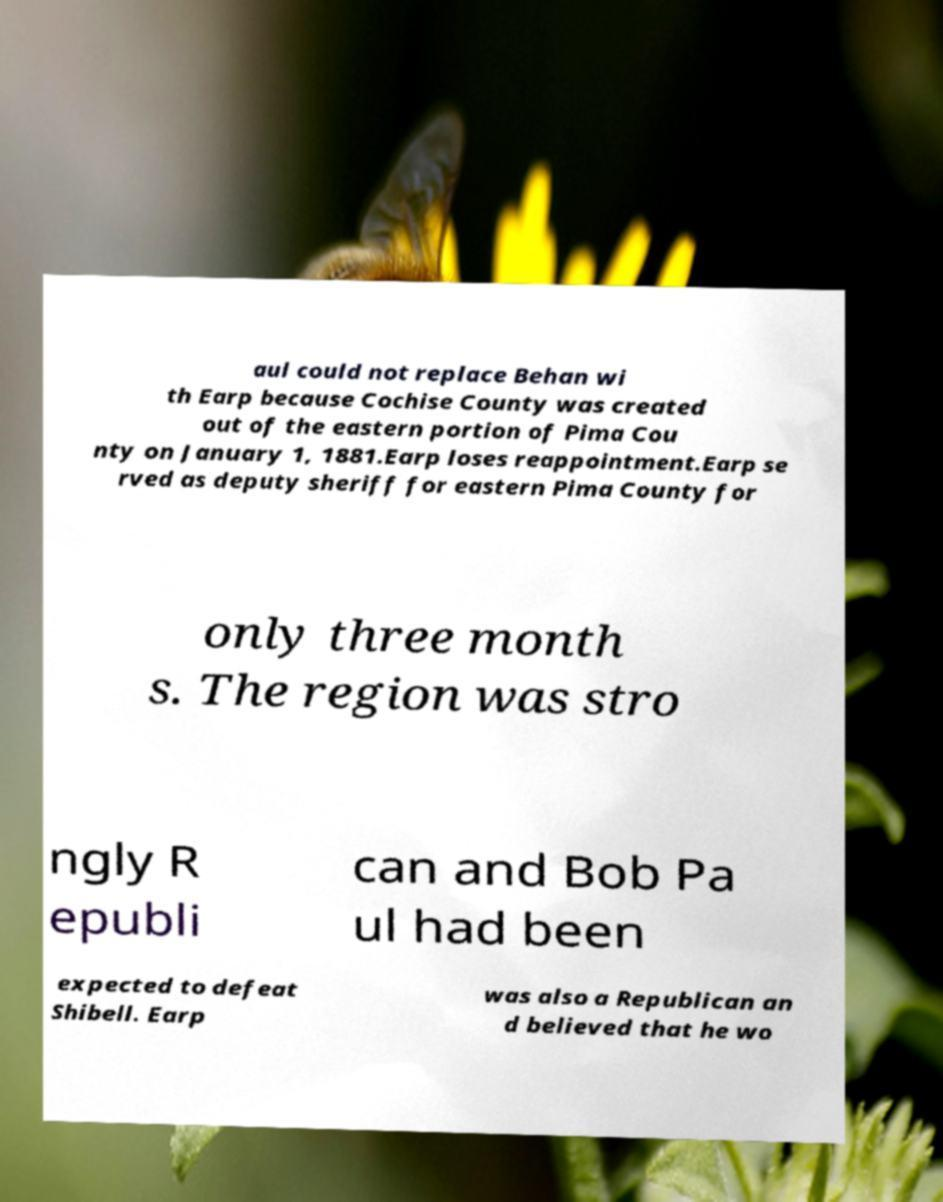Please read and relay the text visible in this image. What does it say? aul could not replace Behan wi th Earp because Cochise County was created out of the eastern portion of Pima Cou nty on January 1, 1881.Earp loses reappointment.Earp se rved as deputy sheriff for eastern Pima County for only three month s. The region was stro ngly R epubli can and Bob Pa ul had been expected to defeat Shibell. Earp was also a Republican an d believed that he wo 